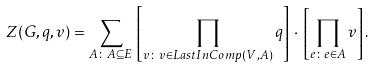<formula> <loc_0><loc_0><loc_500><loc_500>Z ( G , q , v ) = \sum _ { A \colon A \subseteq E } \, \left [ \prod _ { v \colon v \in L a s t I n C o m p ( V , A ) } q \right ] \, \cdot \, \left [ \prod _ { e \colon e \in A } v \right ] .</formula> 